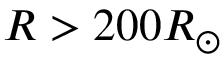Convert formula to latex. <formula><loc_0><loc_0><loc_500><loc_500>R > 2 0 0 R _ { \odot }</formula> 